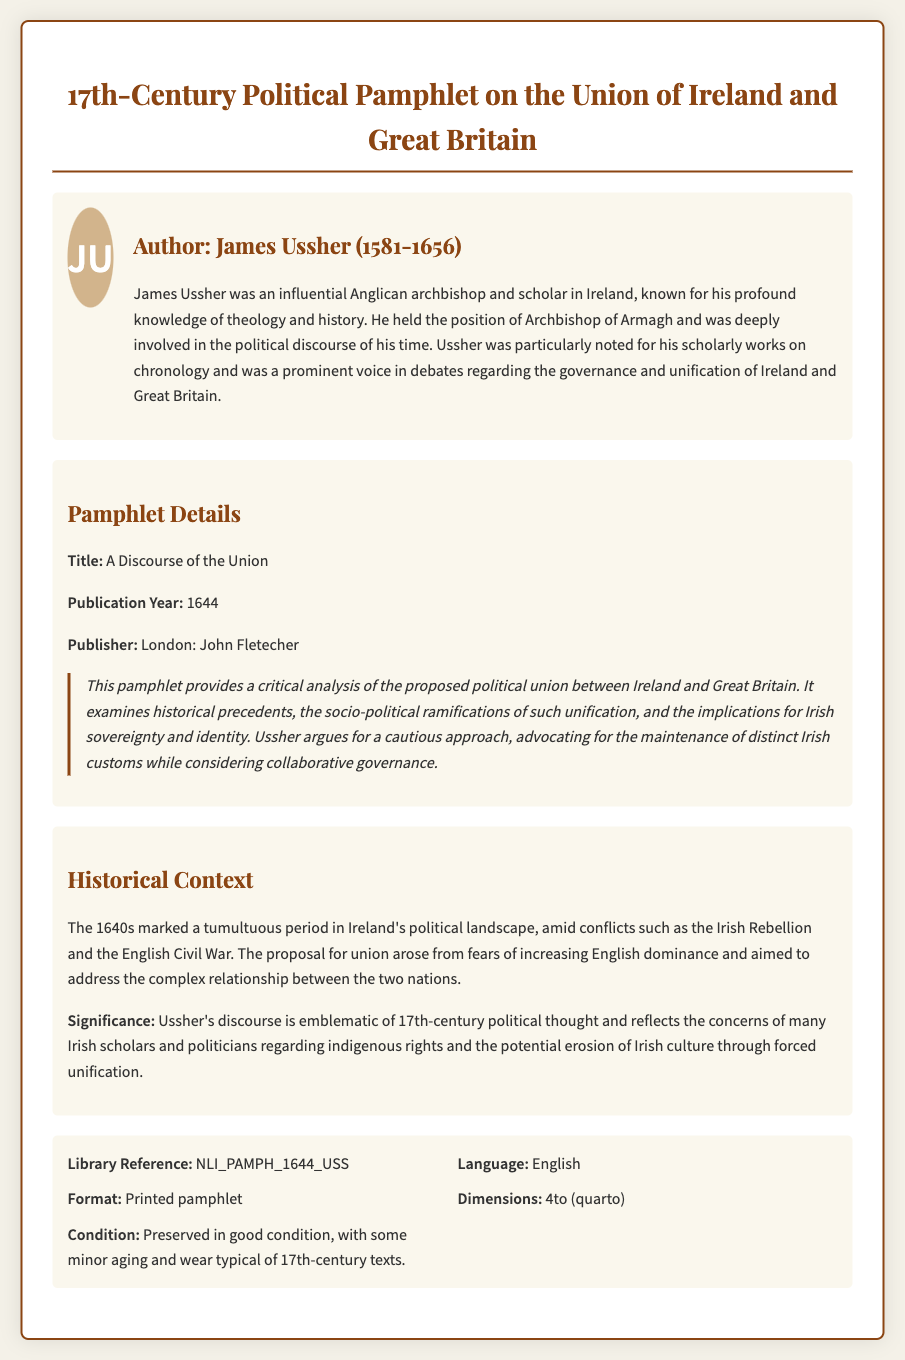What is the title of the pamphlet? The title of the pamphlet is explicitly mentioned in the document under pamphlet details.
Answer: A Discourse of the Union Who is the author of the pamphlet? The document lists James Ussher as the author in the author information section.
Answer: James Ussher What year was the pamphlet published? The publication year is stated in the pamphlet details section of the document.
Answer: 1644 What is the name of the publisher? The publisher's name is included in the pamphlet details, specifying who produced the work.
Answer: John Fletecher What historical events are mentioned in the historical context? The historical context discusses conflicts relevant to the period, indicating key political events.
Answer: Irish Rebellion and the English Civil War What does Ussher advocate for in this pamphlet? The document summarizes Ussher's arguments regarding the approach towards the proposed union.
Answer: Maintenance of distinct Irish customs What is the library reference code for this pamphlet? The specific library reference code is given in the catalog information section of the document.
Answer: NLI_PAMPH_1644_USS What is the format of the document? The format is explicitly described in the catalog information section of the document.
Answer: Printed pamphlet 